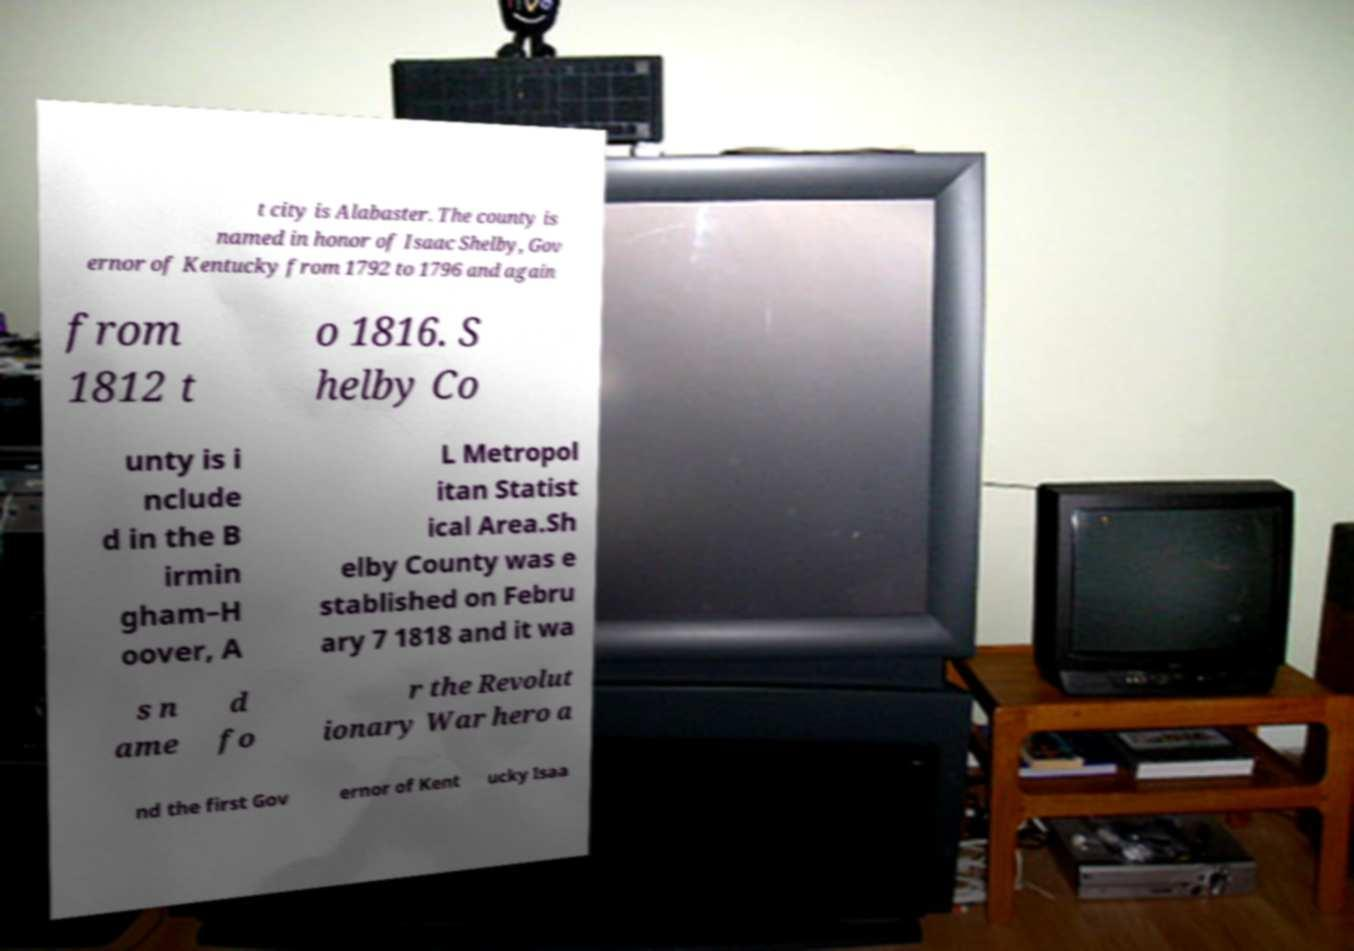Can you read and provide the text displayed in the image?This photo seems to have some interesting text. Can you extract and type it out for me? t city is Alabaster. The county is named in honor of Isaac Shelby, Gov ernor of Kentucky from 1792 to 1796 and again from 1812 t o 1816. S helby Co unty is i nclude d in the B irmin gham–H oover, A L Metropol itan Statist ical Area.Sh elby County was e stablished on Febru ary 7 1818 and it wa s n ame d fo r the Revolut ionary War hero a nd the first Gov ernor of Kent ucky Isaa 